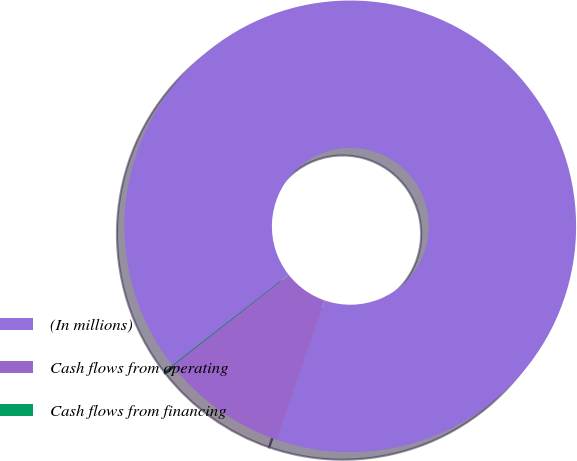Convert chart to OTSL. <chart><loc_0><loc_0><loc_500><loc_500><pie_chart><fcel>(In millions)<fcel>Cash flows from operating<fcel>Cash flows from financing<nl><fcel>90.83%<fcel>9.12%<fcel>0.05%<nl></chart> 